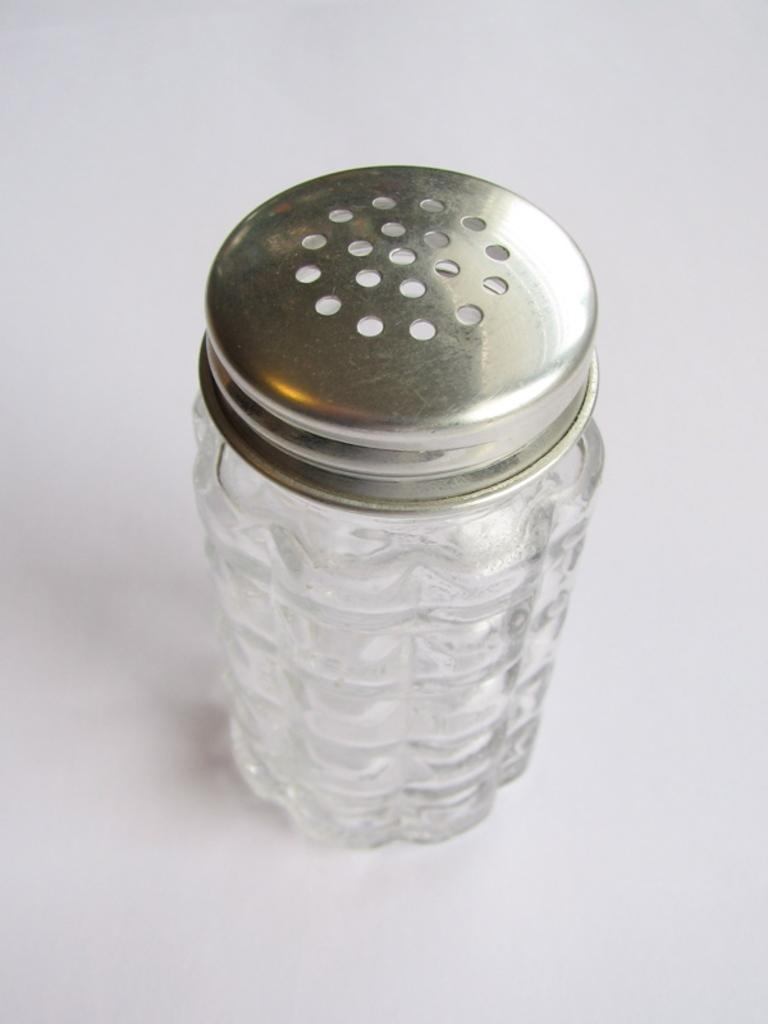What object can be seen in the image? There is a jar in the image. What feature does the jar have? The jar has a lid. What type of calendar is hanging on the wall next to the jar in the image? There is no calendar present in the image; it only features a jar with a lid. 